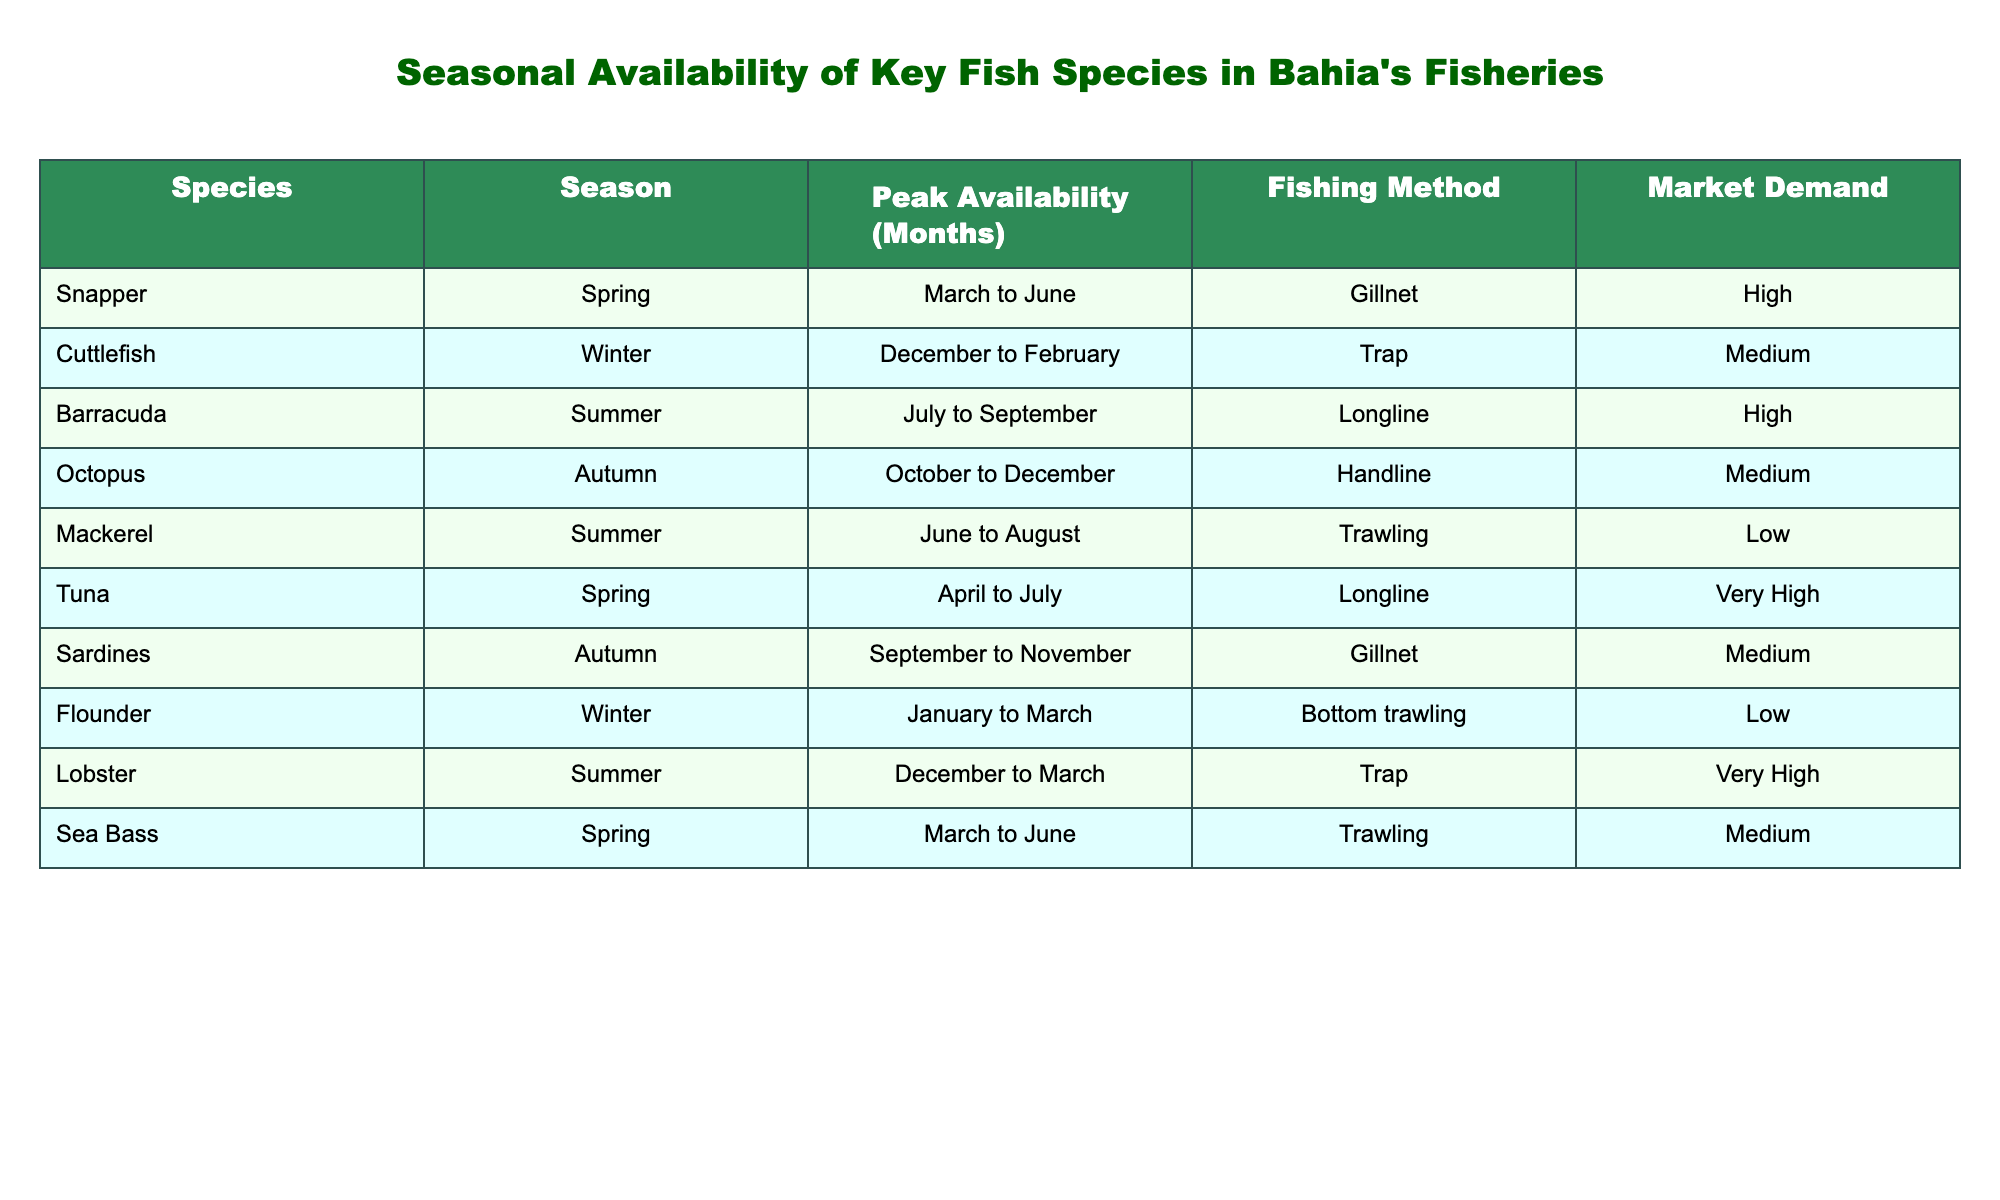What is the fishing method used for Tuna? The table shows that Tuna is available in the Spring season, and the fishing method for Tuna is Longline.
Answer: Longline In which season is Barracuda most available? According to the table, Barracuda peaks in availability during the Summer months from July to September.
Answer: Summer How many species have High market demand? By reviewing the table, the species with High market demand are Snapper, Barracuda, and Tuna. Therefore, there are three species.
Answer: 3 What is the peak availability period for Lobster? The table states that Lobster's peak availability is from December to March during the Summer season.
Answer: December to March Is Mackerel available in the Spring? The table indicates that Mackerel is available in the Summer from June to August, thus it is not available in Spring.
Answer: No Which fishing method is used for Octopus? The table specifies that Octopus is caught using the Handline method in the Autumn season.
Answer: Handline How many species are available in Winter? By examining the table, we find that there are two species available in Winter: Cuttlefish and Flounder.
Answer: 2 Which season has the most species with Very High market demand? The table shows that Lobster in the Summer is the only species with Very High demand, hence Summer has one such species.
Answer: Summer What is the average peak availability duration of species with Medium demand? The species with Medium demand are Cuttlefish, Octopus, Sardines, and Sea Bass. Their peak availability durations are: 3 months (Cuttlefish), 3 months (Octopus), 3 months (Sardines), and 3 months (Sea Bass). The total is 12 months, so the average is 12/4 = 3 months.
Answer: 3 months 